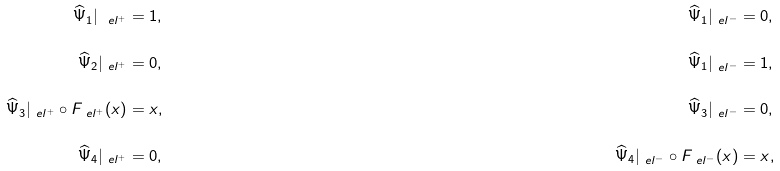<formula> <loc_0><loc_0><loc_500><loc_500>\widehat { \Psi } _ { 1 } | _ { \ e l ^ { + } } & = 1 , & \widehat { \Psi } _ { 1 } | _ { \ e l ^ { - } } & = 0 , \\ \widehat { \Psi } _ { 2 } | _ { \ e l ^ { + } } & = 0 , & \widehat { \Psi } _ { 1 } | _ { \ e l ^ { - } } & = 1 , \\ \widehat { \Psi } _ { 3 } | _ { \ e l ^ { + } } \circ F _ { \ e l ^ { + } } ( x ) & = x , & \widehat { \Psi } _ { 3 } | _ { \ e l ^ { - } } & = 0 , \\ \widehat { \Psi } _ { 4 } | _ { \ e l ^ { + } } & = 0 , & \widehat { \Psi } _ { 4 } | _ { \ e l ^ { - } } \circ F _ { \ e l ^ { - } } ( x ) & = x ,</formula> 